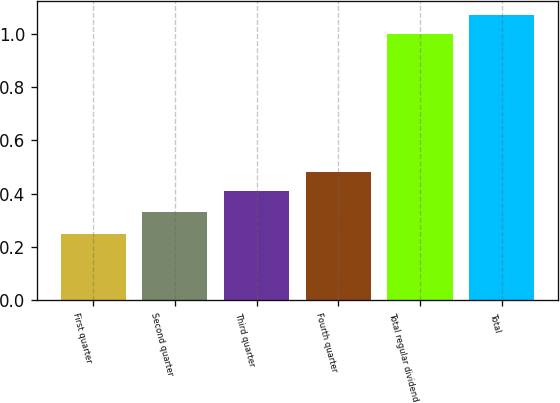Convert chart. <chart><loc_0><loc_0><loc_500><loc_500><bar_chart><fcel>First quarter<fcel>Second quarter<fcel>Third quarter<fcel>Fourth quarter<fcel>Total regular dividend<fcel>Total<nl><fcel>0.25<fcel>0.33<fcel>0.41<fcel>0.48<fcel>1<fcel>1.07<nl></chart> 